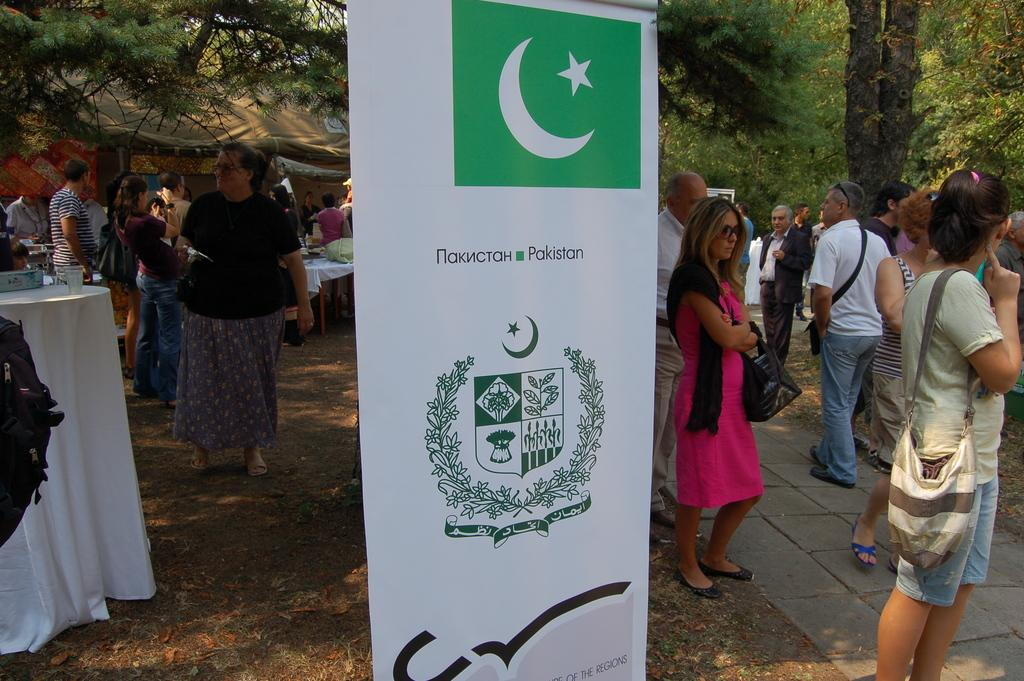What is the main object in the front of the image? There is a white and green rolling banner in the front of the image. What can be seen behind the banner? There are men and women standing in the ground behind the banner. What type of vegetation is visible in the background of the image? There are trees visible in the background of the image. Can you tell me how many zebras are standing behind the banner in the image? There are no zebras present in the image; only men and women are standing behind the banner. What type of step is visible in the image? There is no specific step mentioned or visible in the image. 